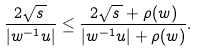<formula> <loc_0><loc_0><loc_500><loc_500>\frac { 2 \sqrt { s \, } } { | w ^ { - 1 } u | } \leq \frac { 2 \sqrt { s \, } + \rho ( w ) } { | w ^ { - 1 } u | + \rho ( w ) } .</formula> 